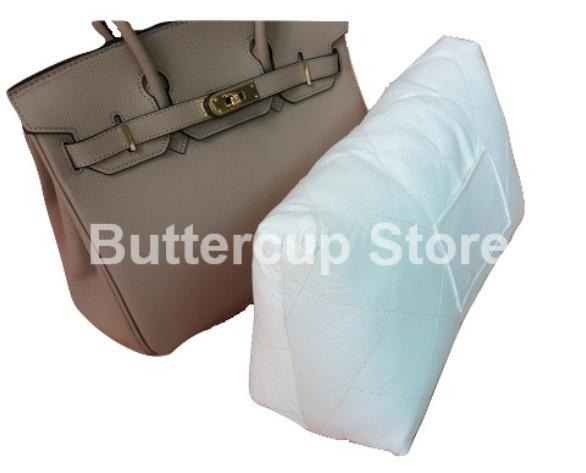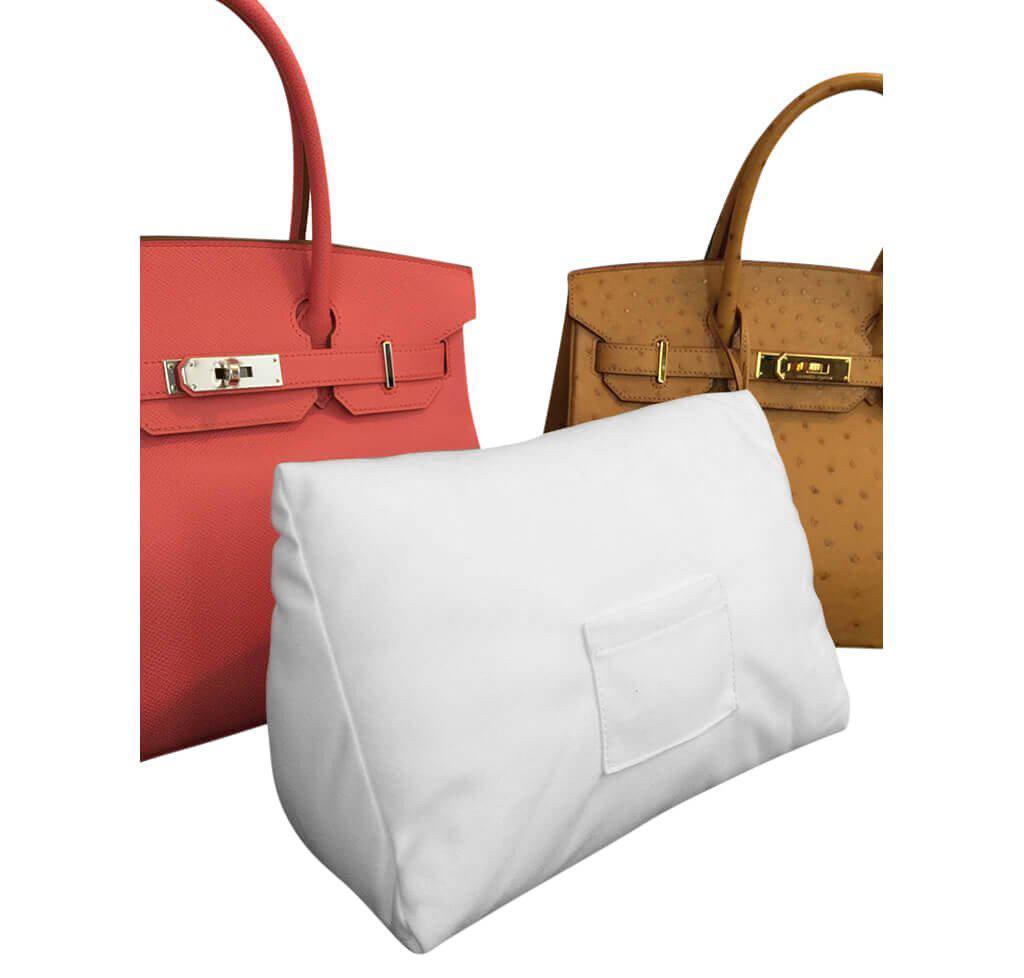The first image is the image on the left, the second image is the image on the right. For the images displayed, is the sentence "The right image shows an upright coral-colored handbag to the left of an upright tan handbag, and a white wedge pillow is in front of them." factually correct? Answer yes or no. Yes. The first image is the image on the left, the second image is the image on the right. Considering the images on both sides, is "The image on the right shows two purses and a purse pillow." valid? Answer yes or no. Yes. 